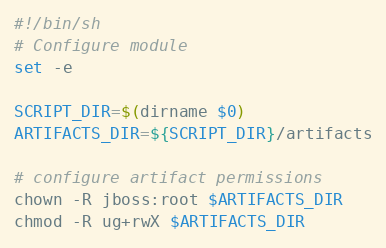<code> <loc_0><loc_0><loc_500><loc_500><_Bash_>#!/bin/sh
# Configure module
set -e

SCRIPT_DIR=$(dirname $0)
ARTIFACTS_DIR=${SCRIPT_DIR}/artifacts

# configure artifact permissions
chown -R jboss:root $ARTIFACTS_DIR
chmod -R ug+rwX $ARTIFACTS_DIR</code> 